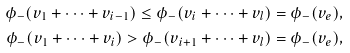Convert formula to latex. <formula><loc_0><loc_0><loc_500><loc_500>\phi _ { - } ( v _ { 1 } + \cdots + v _ { i - 1 } ) \leq \phi _ { - } ( v _ { i } + \cdots + v _ { l } ) = \phi _ { - } ( v _ { e } ) , \\ \phi _ { - } ( v _ { 1 } + \cdots + v _ { i } ) > \phi _ { - } ( v _ { i + 1 } + \cdots + v _ { l } ) = \phi _ { - } ( v _ { e } ) ,</formula> 